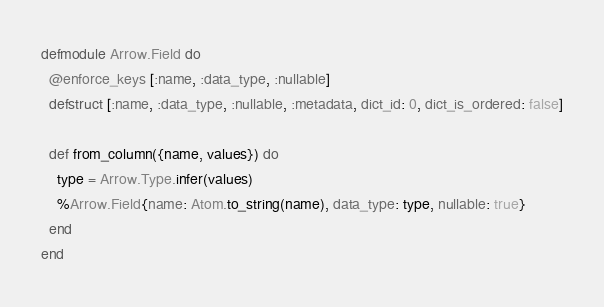<code> <loc_0><loc_0><loc_500><loc_500><_Elixir_>defmodule Arrow.Field do
  @enforce_keys [:name, :data_type, :nullable]
  defstruct [:name, :data_type, :nullable, :metadata, dict_id: 0, dict_is_ordered: false]

  def from_column({name, values}) do
    type = Arrow.Type.infer(values)
    %Arrow.Field{name: Atom.to_string(name), data_type: type, nullable: true}
  end
end
</code> 